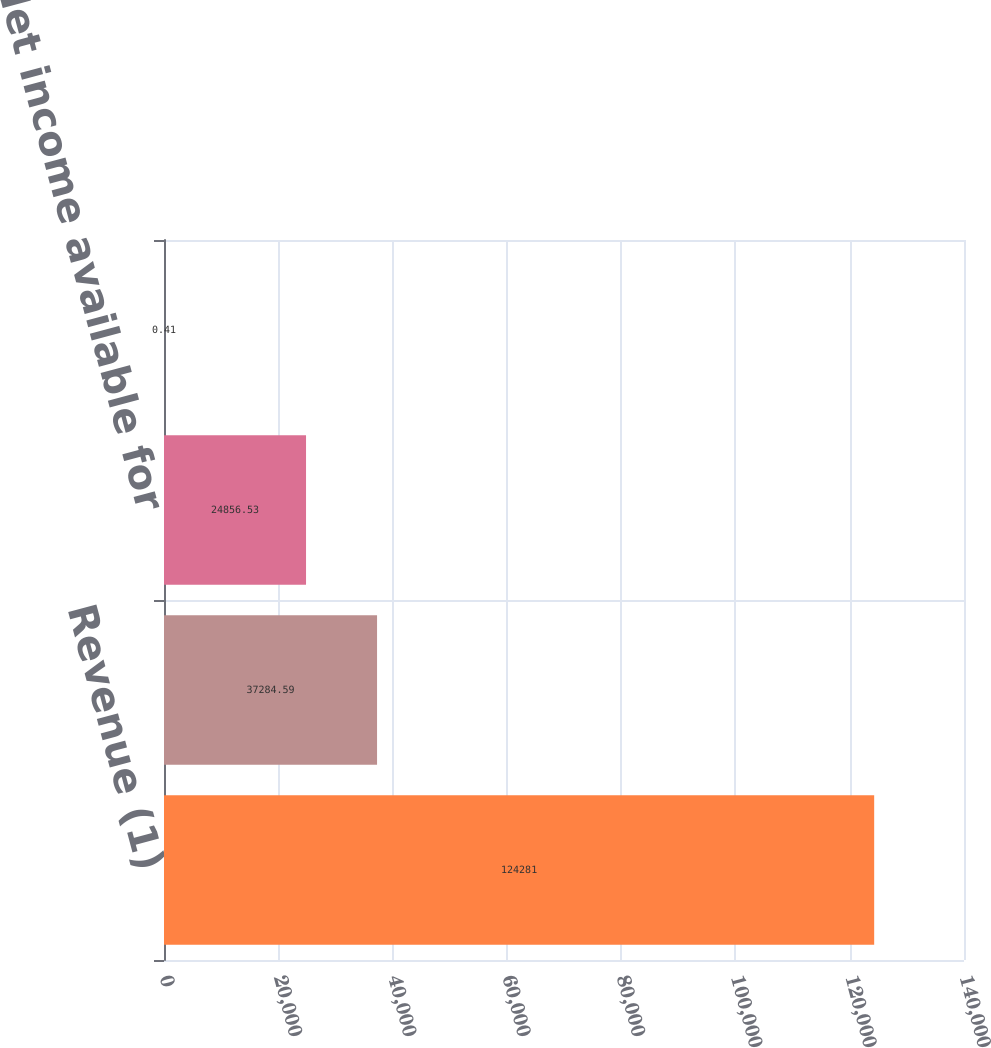Convert chart. <chart><loc_0><loc_0><loc_500><loc_500><bar_chart><fcel>Revenue (1)<fcel>Net income<fcel>Net income available for<fcel>Earnings per common<nl><fcel>124281<fcel>37284.6<fcel>24856.5<fcel>0.41<nl></chart> 